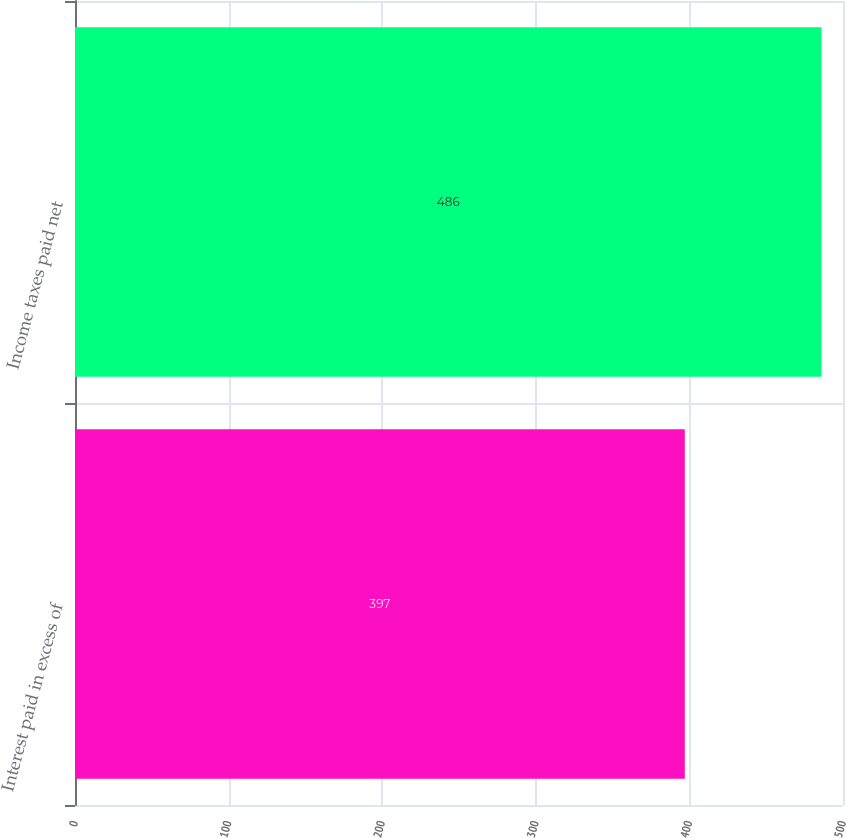<chart> <loc_0><loc_0><loc_500><loc_500><bar_chart><fcel>Interest paid in excess of<fcel>Income taxes paid net<nl><fcel>397<fcel>486<nl></chart> 